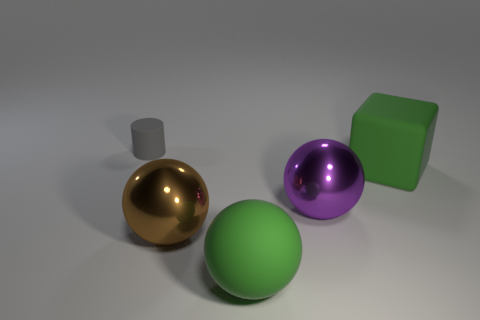Subtract all large purple metal spheres. How many spheres are left? 2 Add 3 yellow rubber blocks. How many objects exist? 8 Subtract all cubes. How many objects are left? 4 Subtract all yellow balls. Subtract all yellow cylinders. How many balls are left? 3 Subtract 0 cyan cubes. How many objects are left? 5 Subtract all green rubber things. Subtract all gray metal blocks. How many objects are left? 3 Add 5 large purple metallic things. How many large purple metallic things are left? 6 Add 4 large cyan cylinders. How many large cyan cylinders exist? 4 